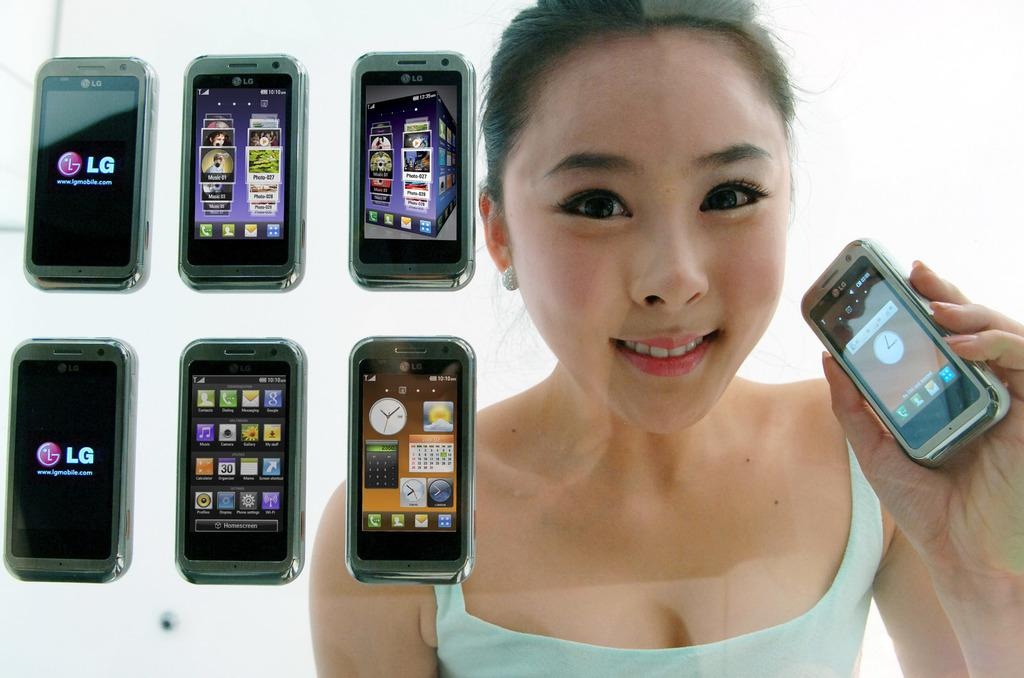<image>
Give a short and clear explanation of the subsequent image. an LG phone that is near a girl 